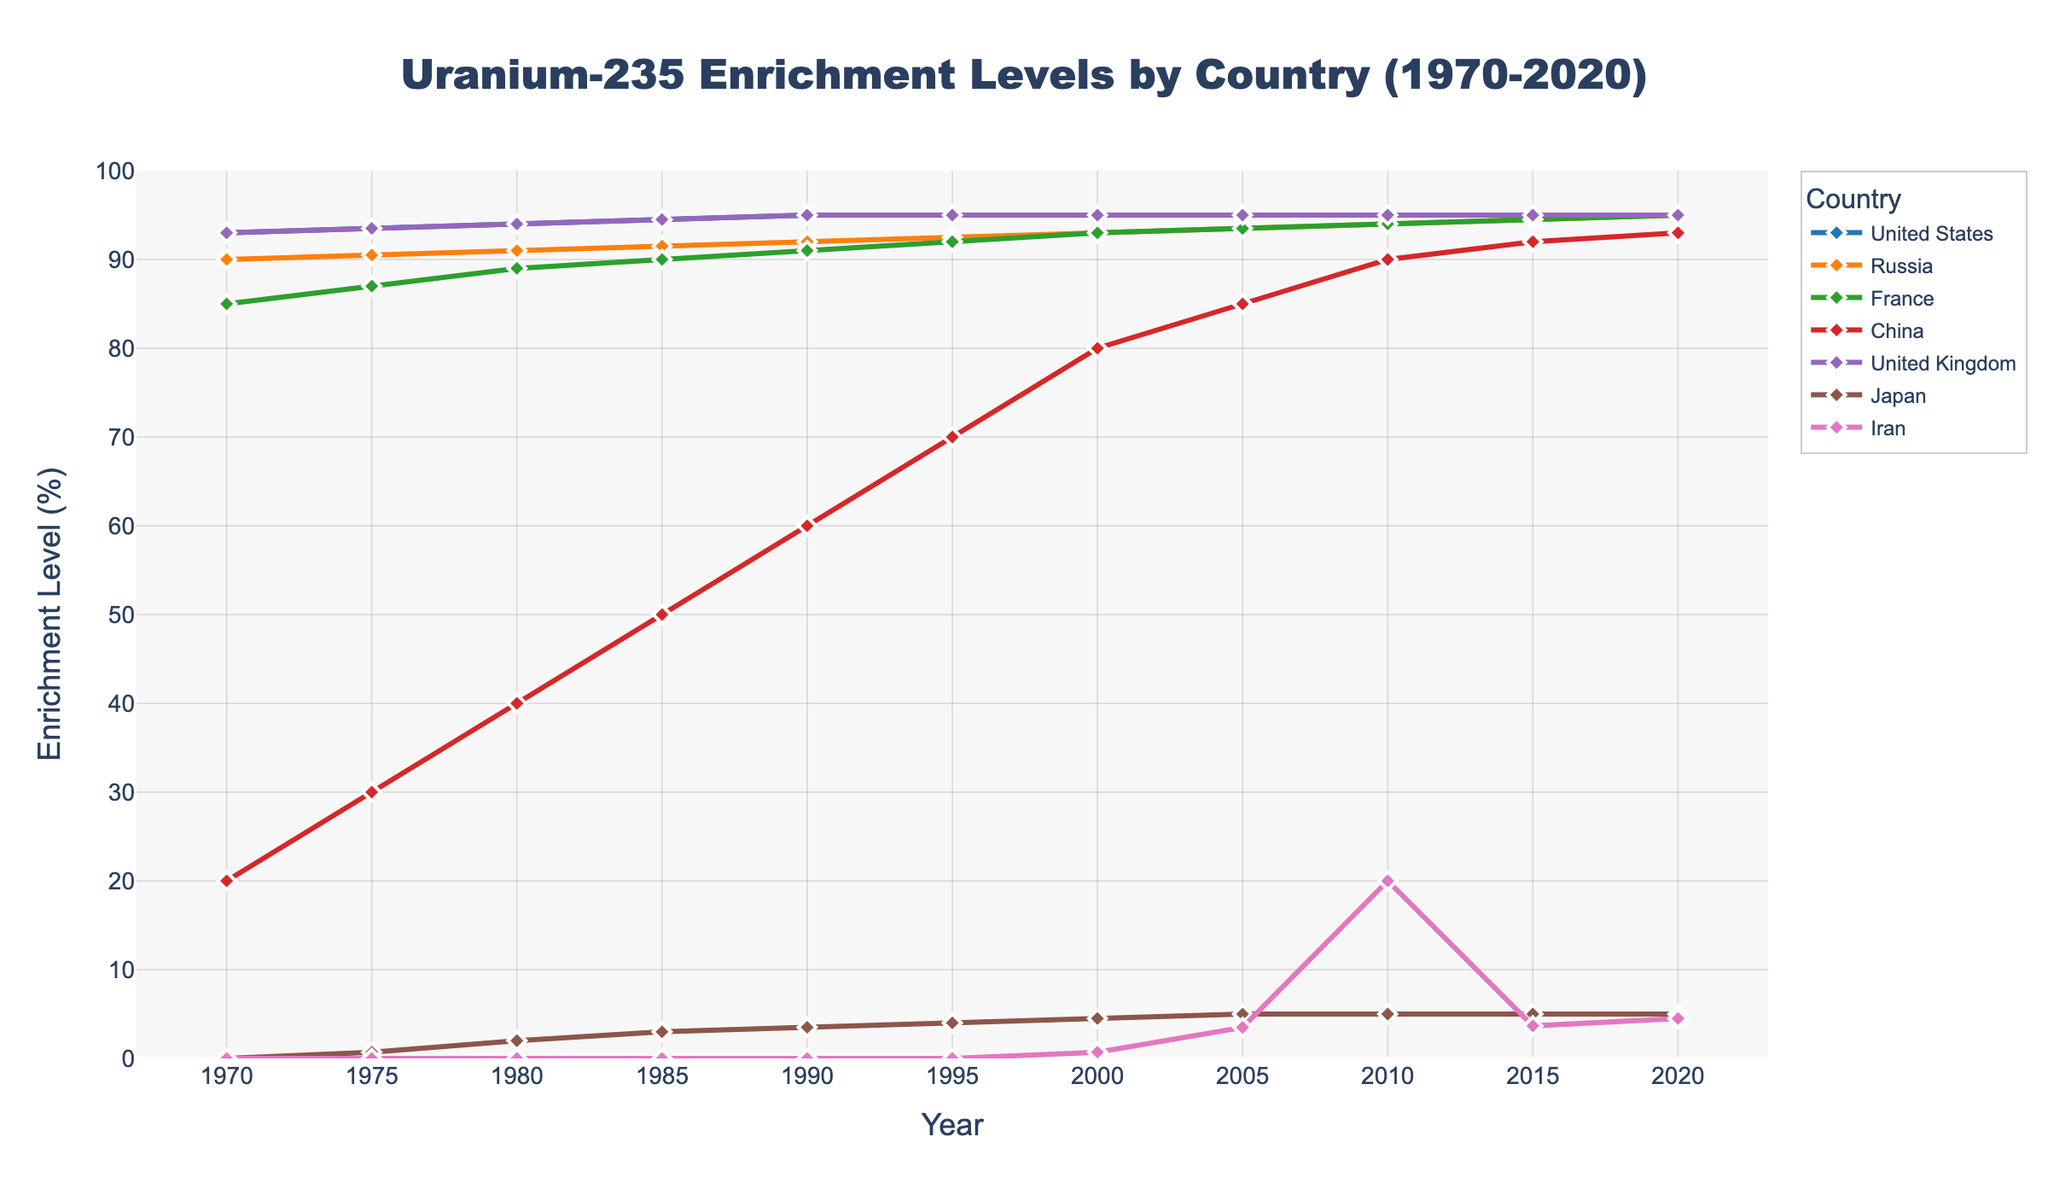When did China surpass France in its uranium-235 enrichment levels for the first time? China surpassed France in the year 2000, where its enrichment level reached 80%, which was higher than France’s 70% in the same year.
Answer: 2000 Which country has consistently maintained the highest enrichment levels since 1970? The United States, United Kingdom, and Russia have consistently maintained the highest enrichment levels, reaching up to 95%, with the United States and United Kingdom always maintaining at least 90% levels throughout the years.
Answer: United States and United Kingdom Between 1970 and 1980, which country had the most significant increase in enrichment levels? China had the most significant increase in enrichment levels between 1970 and 1980, with an increase from 20% to 40%, a total of 20 percentage points.
Answer: China Compare the trend of enrichment levels in Russia and Japan from 1970 to 2020. What pattern do you observe? Russia's enrichment levels steadily increased from 90% (1970) to 95% (2020). Japan's enrichment levels started at 0% (1970) and increased gradually to 5% (2020). Russia's enrichment levels increased consistently while Japan's started later and increased more gradually.
Answer: Consistent growth for Russia, gradual and starting later for Japan What was the average enrichment level of Iran from 2010 to 2020? The enrichment levels of Iran from 2010 to 2020 were 20%, 3.67%, and 4.5%. To find the average: (20 + 3.67 + 4.5) / 3 = 28.17 / 3 ≈ 9.39
Answer: 9.39% From the data, which countries’ enrichment levels remained unchanged from 2000 to 2020? The United States and United Kingdom maintained a consistent enrichment level of 95% from 2000 to 2020.
Answer: United States and United Kingdom In what year did Japan’s enrichment level reach 5% for the first time? Japan’s enrichment level reached 5% for the first time in the year 2005.
Answer: 2005 Over the entire period, which country experienced the smallest change in enrichment levels? The United Kingdom experienced the smallest change, starting at and maintaining 93% from 1970 and only reaching 95% eventually.
Answer: United Kingdom Was there any point where Iran's enrichment level exceeded 20%? No, Iran's highest enrichment level in the period was 20% in the year 2010.
Answer: No 